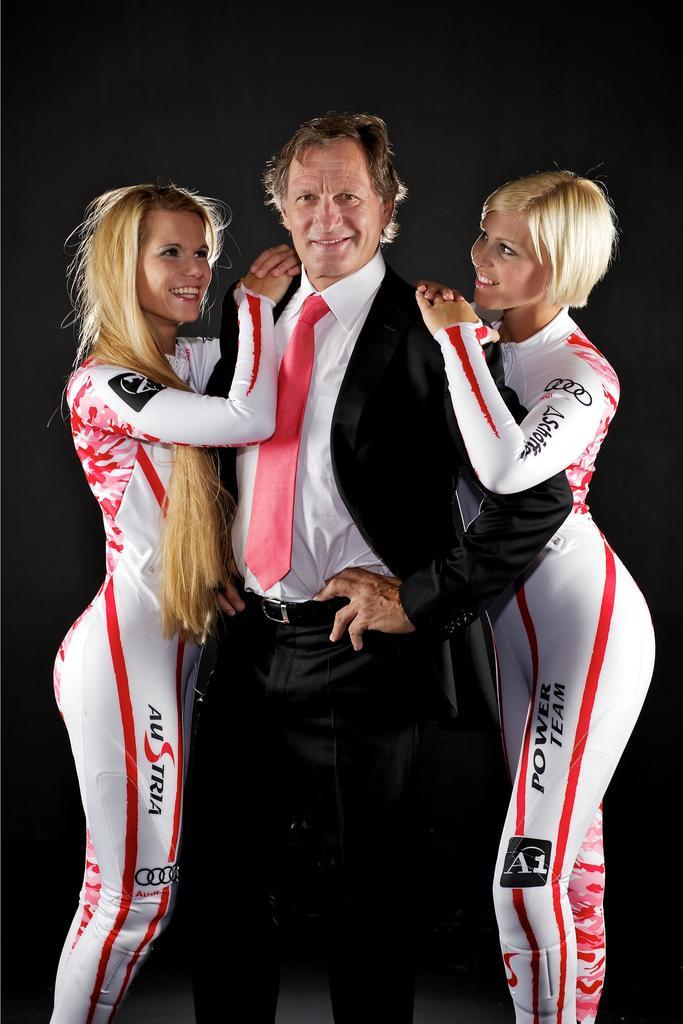<image>
Share a concise interpretation of the image provided. The guy has two girl models advertising power team Austria. 